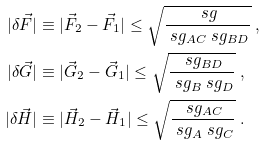<formula> <loc_0><loc_0><loc_500><loc_500>| \delta \vec { F } | & \equiv | \vec { F } _ { 2 } - \vec { F } _ { 1 } | \leq \sqrt { \frac { \ s g } { \ s g _ { A C } \ s g _ { B D } } } \ , \\ | \delta \vec { G } | & \equiv | \vec { G } _ { 2 } - \vec { G } _ { 1 } | \leq \sqrt { \frac { \ s g _ { B D } } { \ s g _ { B } \ s g _ { D } } } \ , \\ | \delta \vec { H } | & \equiv | \vec { H } _ { 2 } - \vec { H } _ { 1 } | \leq \sqrt { \frac { \ s g _ { A C } } { \ s g _ { A } \ s g _ { C } } } \ .</formula> 